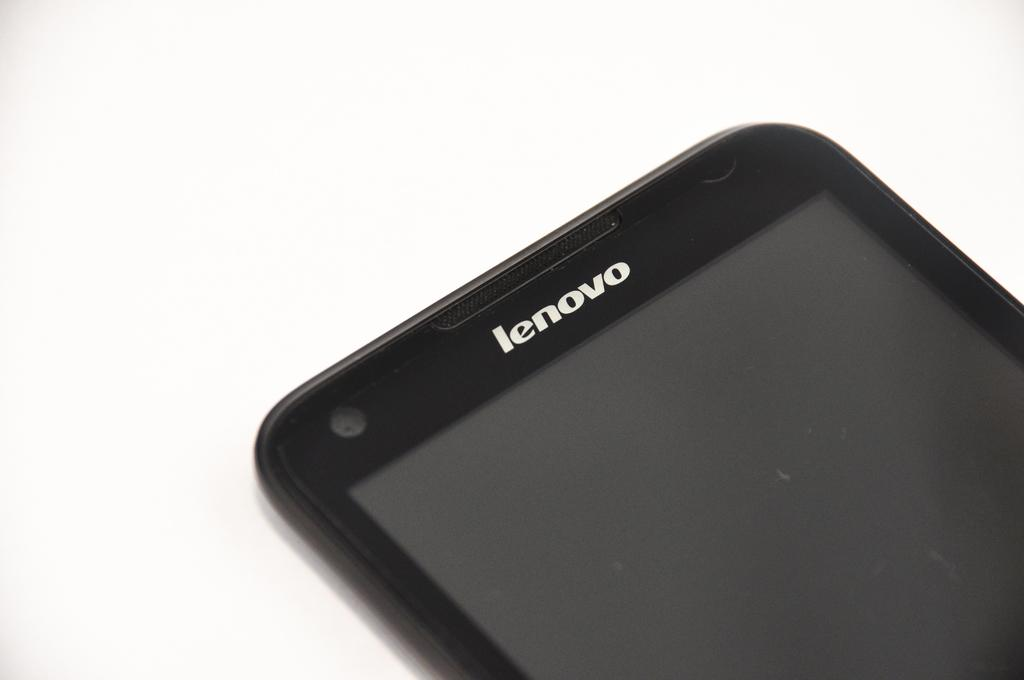<image>
Present a compact description of the photo's key features. The front of a Lenovo phone that is currently off 